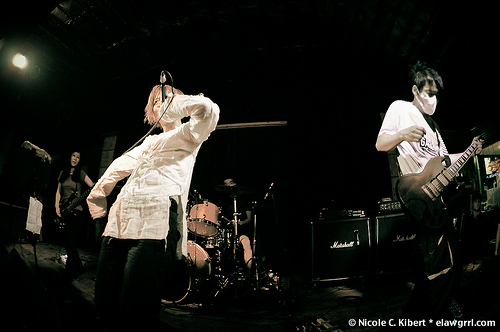<image>
Is the singer behind the drums? No. The singer is not behind the drums. From this viewpoint, the singer appears to be positioned elsewhere in the scene. 